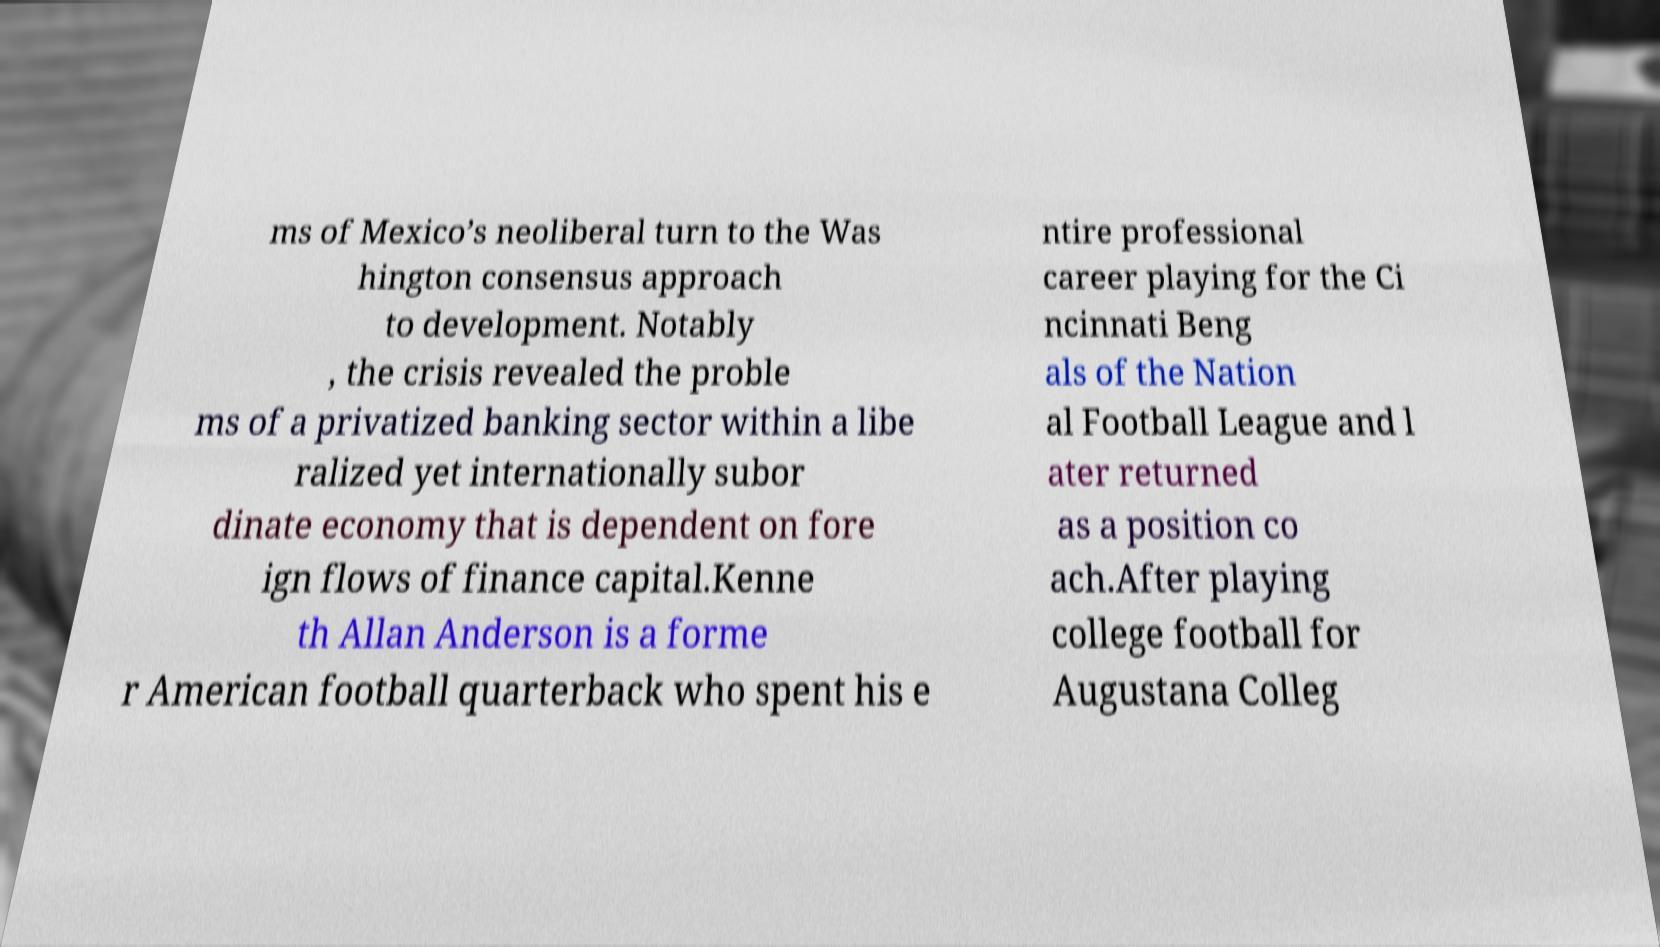What messages or text are displayed in this image? I need them in a readable, typed format. ms of Mexico’s neoliberal turn to the Was hington consensus approach to development. Notably , the crisis revealed the proble ms of a privatized banking sector within a libe ralized yet internationally subor dinate economy that is dependent on fore ign flows of finance capital.Kenne th Allan Anderson is a forme r American football quarterback who spent his e ntire professional career playing for the Ci ncinnati Beng als of the Nation al Football League and l ater returned as a position co ach.After playing college football for Augustana Colleg 